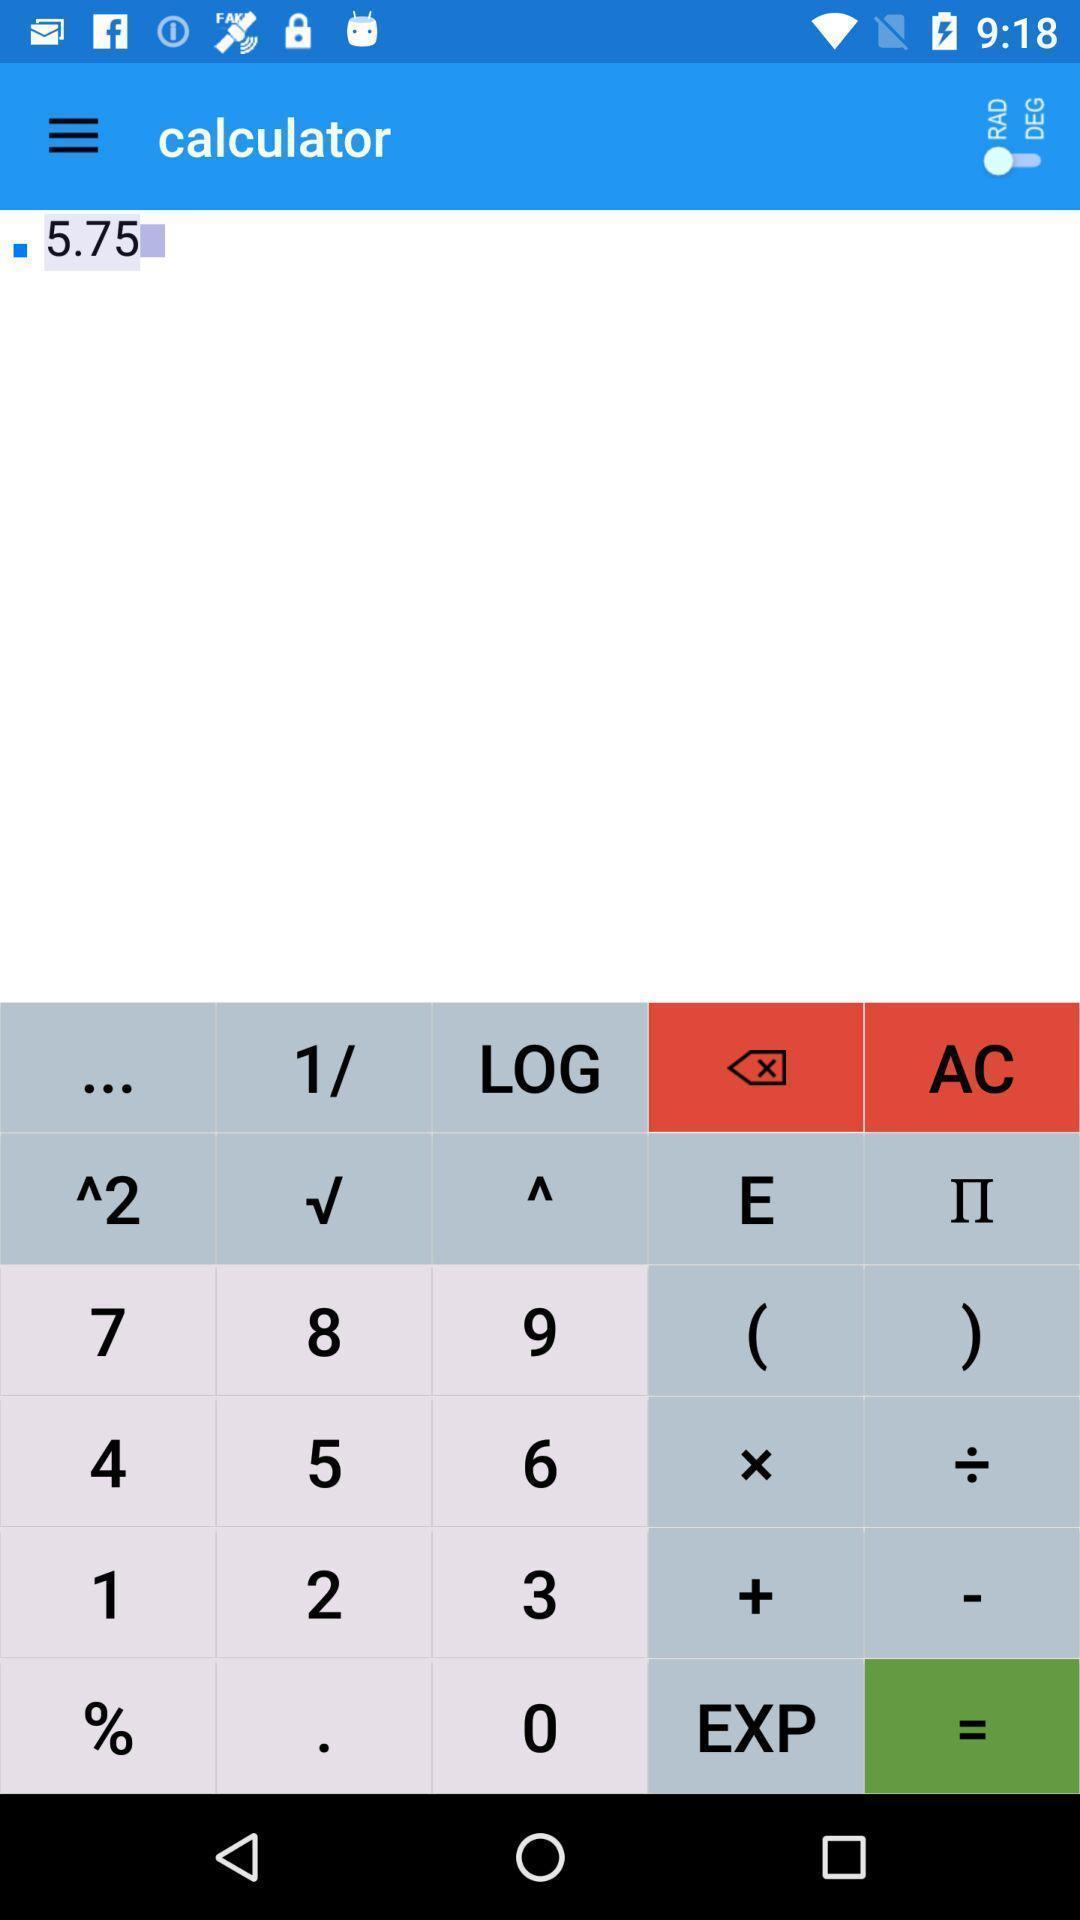What can you discern from this picture? Page showing different values for calculation. 